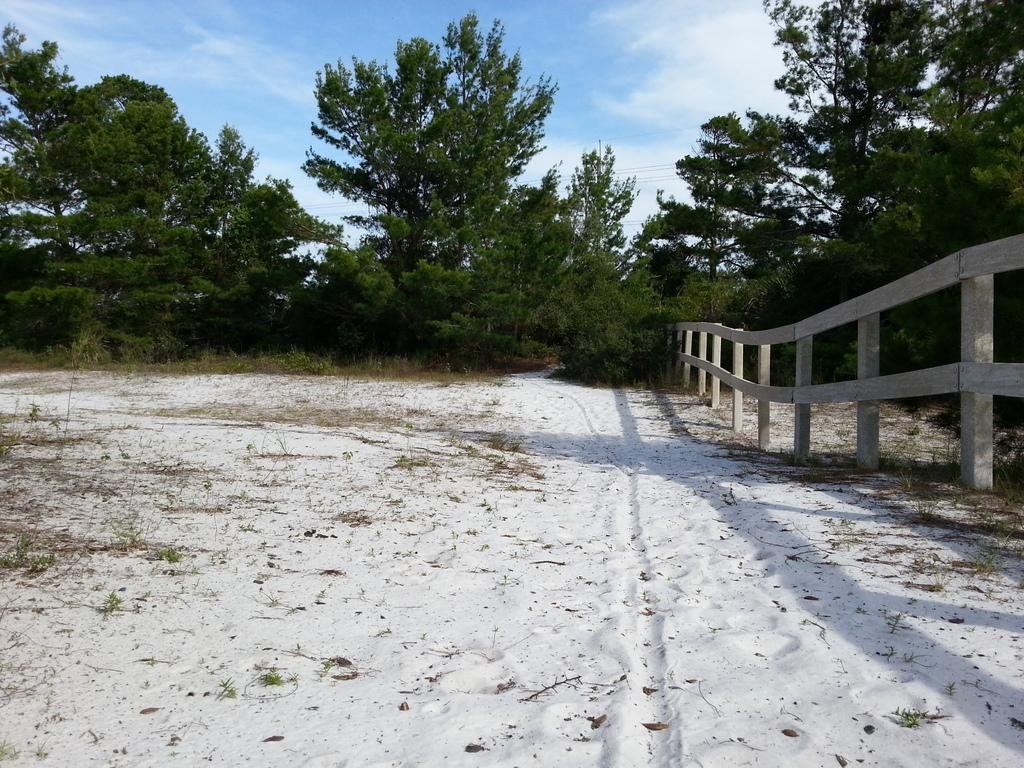What type of barrier is present in the image? There is a wooden fence in the image. Where is the wooden fence located? The wooden fence is in the sand. What can be seen in the background of the image? There are trees and the sky visible in the background of the image. What is the condition of the sky in the image? Clouds are present in the sky. How does the fence's aunt react to the knowledge of the crying child in the image? There is no aunt, crying child, or knowledge of any such situation present in the image. 